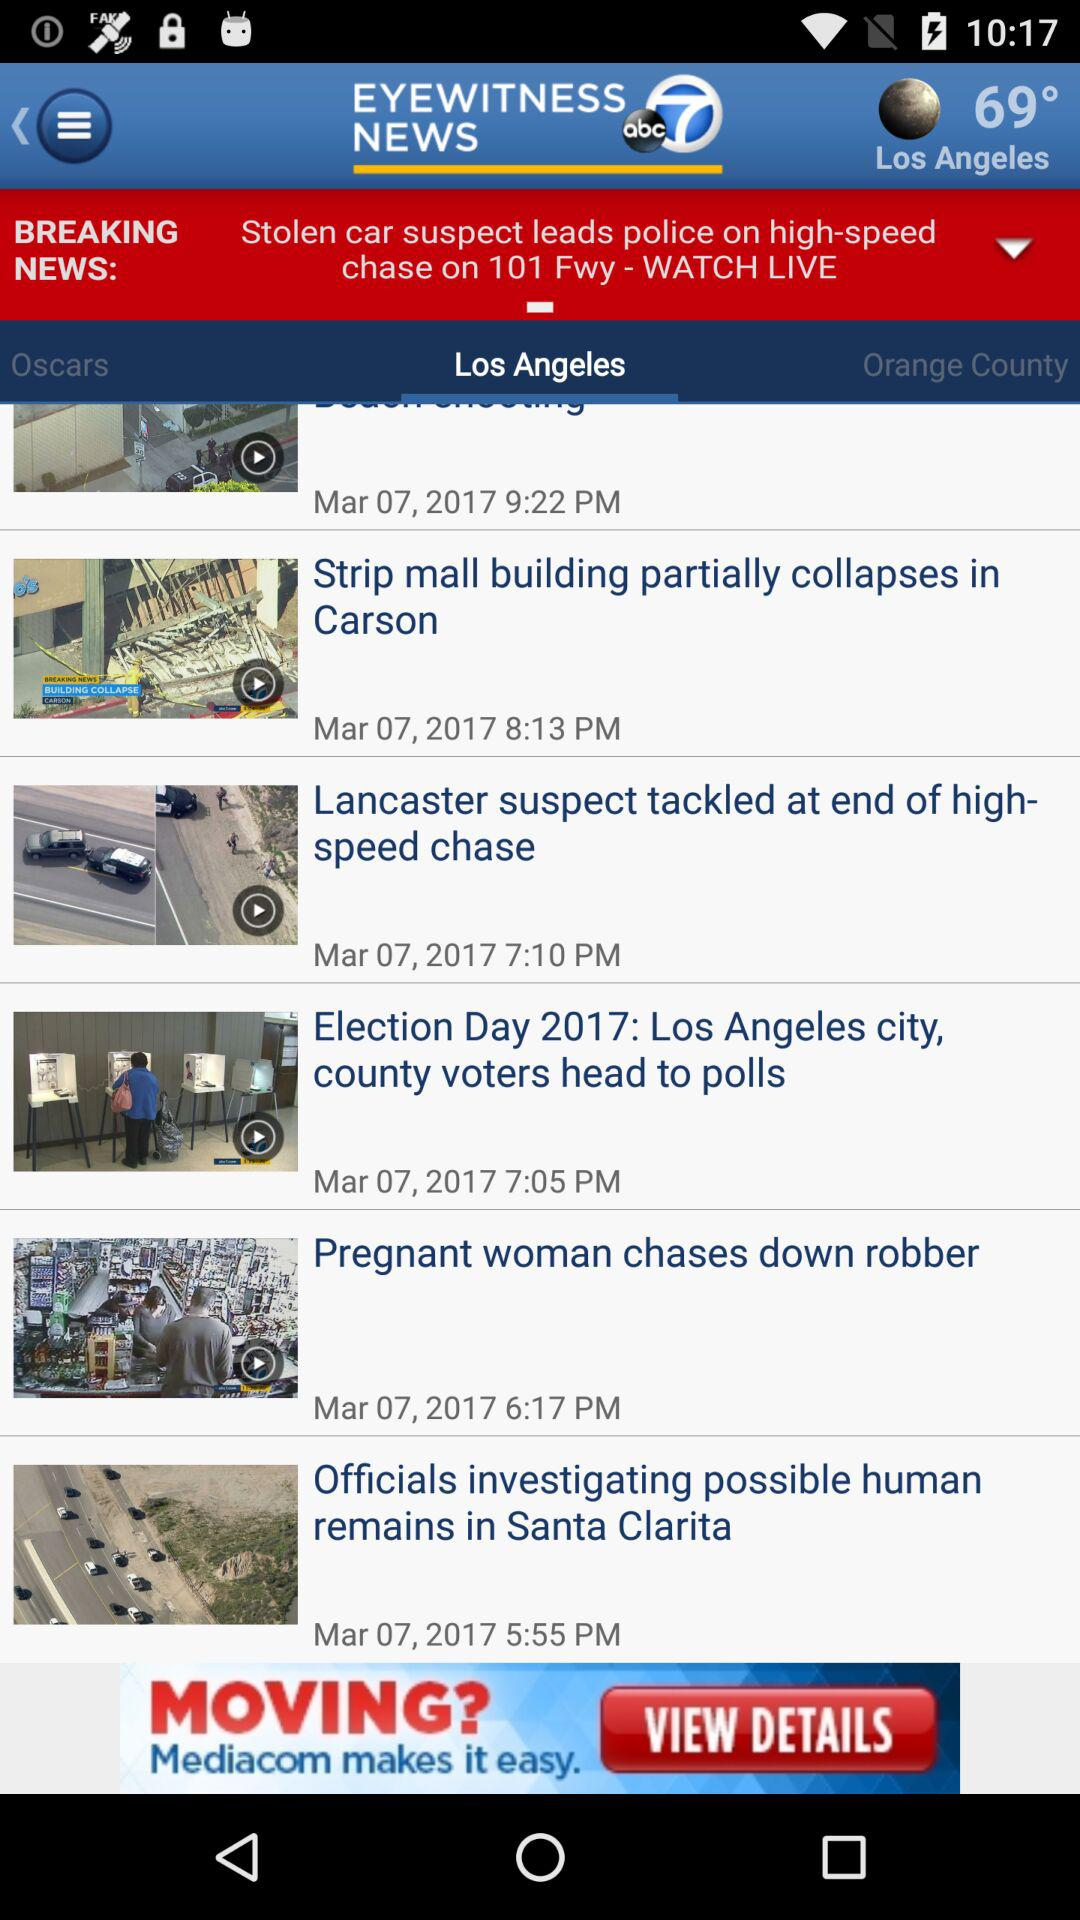What is the temperature in Los Angeles? The temperature is 69°. 